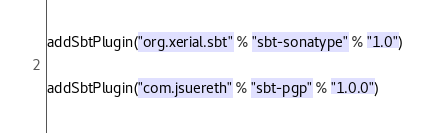Convert code to text. <code><loc_0><loc_0><loc_500><loc_500><_Scala_>addSbtPlugin("org.xerial.sbt" % "sbt-sonatype" % "1.0")

addSbtPlugin("com.jsuereth" % "sbt-pgp" % "1.0.0")
</code> 